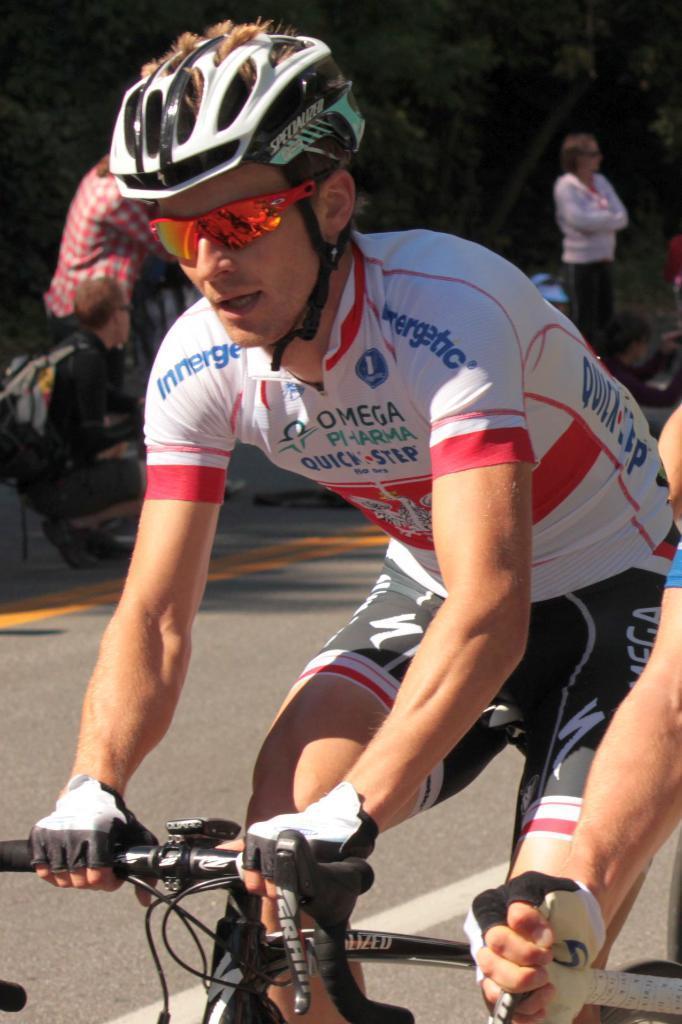How would you summarize this image in a sentence or two? In this image we can see a few people standing and the other person riding a bicycle on the road. And at the back we can see the person sitting and there are trees. 